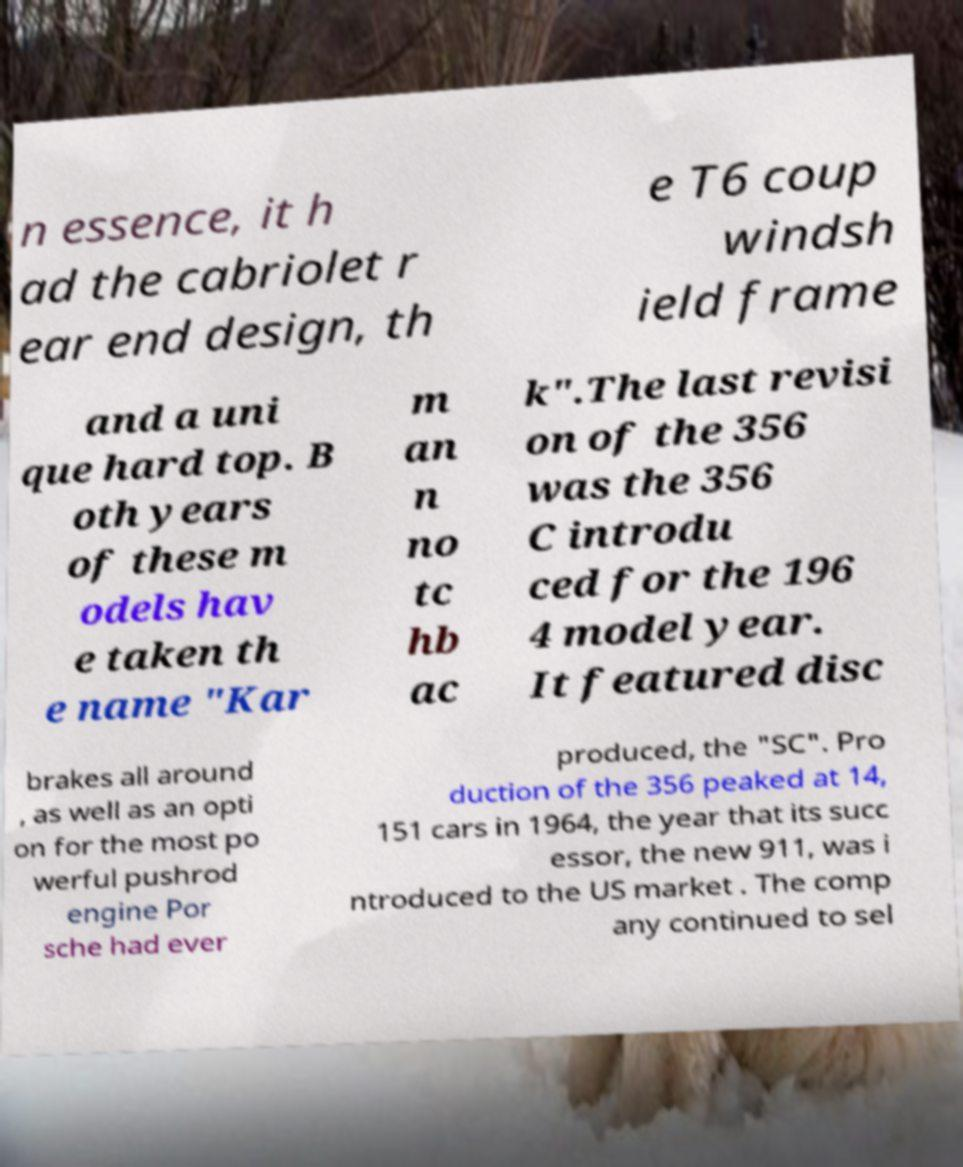I need the written content from this picture converted into text. Can you do that? n essence, it h ad the cabriolet r ear end design, th e T6 coup windsh ield frame and a uni que hard top. B oth years of these m odels hav e taken th e name "Kar m an n no tc hb ac k".The last revisi on of the 356 was the 356 C introdu ced for the 196 4 model year. It featured disc brakes all around , as well as an opti on for the most po werful pushrod engine Por sche had ever produced, the "SC". Pro duction of the 356 peaked at 14, 151 cars in 1964, the year that its succ essor, the new 911, was i ntroduced to the US market . The comp any continued to sel 